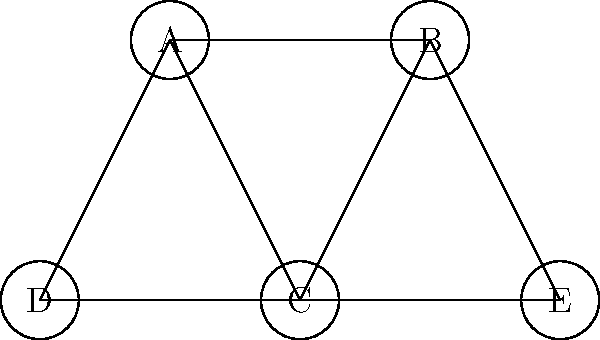In the book recommendation network shown above, nodes represent books and edges represent shared reader preferences. If you're planning a road trip and want to maximize the number of book recommendations you can discuss with your partner, what is the minimum number of books you need to select to cover all preference connections in the network? To solve this problem, we need to find the minimum vertex cover of the graph. A vertex cover is a set of vertices such that every edge in the graph is incident to at least one vertex in the set. Here's how we can approach this step-by-step:

1. Observe the graph structure:
   - There are 5 nodes (A, B, C, D, E) representing books.
   - There are 7 edges representing shared reader preferences.

2. Look for nodes with high degree (connected to many edges):
   - Node A is connected to 3 edges.
   - Node B is connected to 3 edges.
   - Node C is connected to 4 edges.
   - Nodes D and E are connected to 1 and 2 edges respectively.

3. Start with the highest degree node, C:
   - Selecting C covers 4 out of 7 edges.

4. Look for the next node that covers the most remaining edges:
   - Node A or B would cover 2 more edges.
   - Let's choose A (the choice between A and B doesn't affect the final count).

5. Check if all edges are covered:
   - Selecting C and A covers 6 out of 7 edges.
   - The only uncovered edge is between B and E.

6. Select either B or E to cover the last edge:
   - Let's choose B (again, the choice doesn't affect the final count).

7. Verify that all edges are now covered by the selected nodes C, A, and B.

Therefore, the minimum number of books needed to cover all preference connections is 3.
Answer: 3 